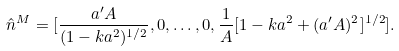Convert formula to latex. <formula><loc_0><loc_0><loc_500><loc_500>\hat { n } ^ { M } = [ \frac { a ^ { \prime } A } { ( 1 - k a ^ { 2 } ) ^ { 1 / 2 } } , 0 , \dots , 0 , \frac { 1 } { A } [ 1 - k a ^ { 2 } + ( a ^ { \prime } A ) ^ { 2 } ] ^ { 1 / 2 } ] .</formula> 